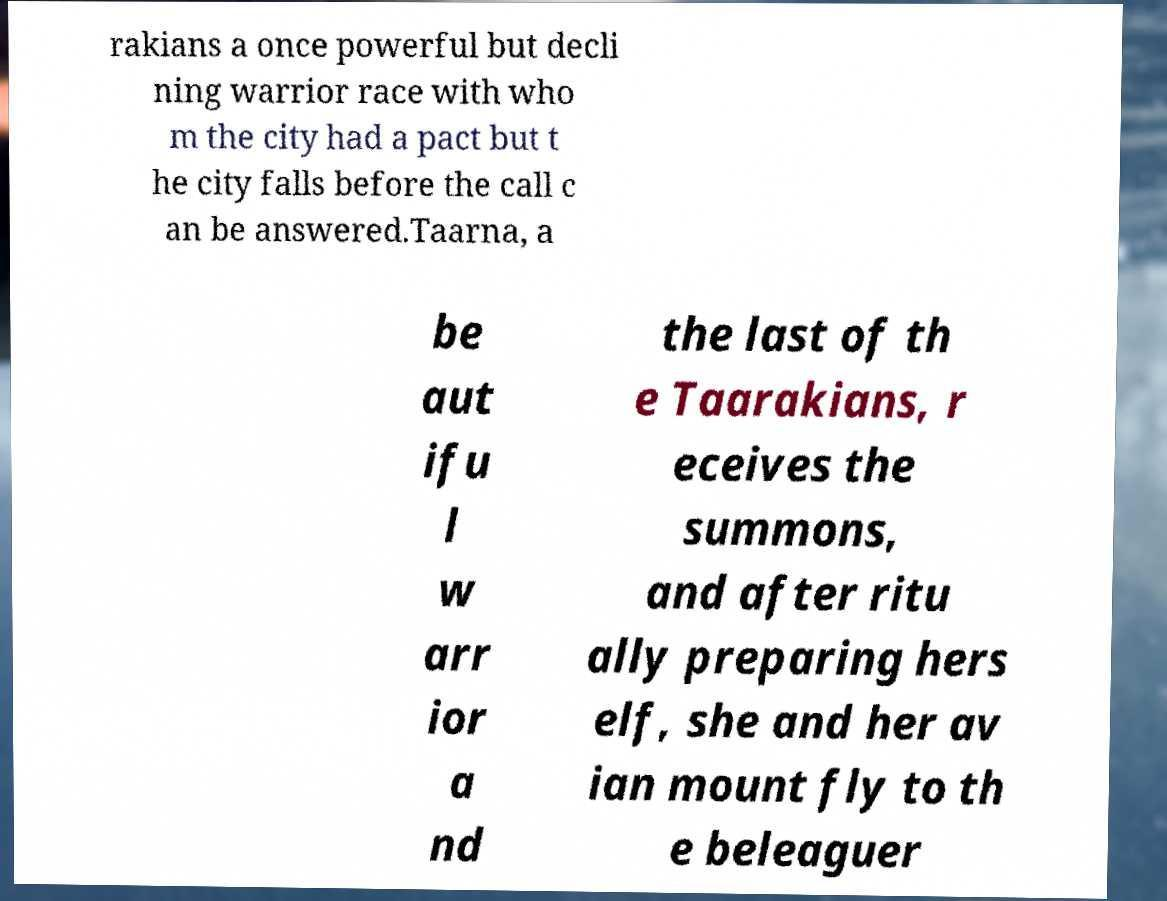For documentation purposes, I need the text within this image transcribed. Could you provide that? rakians a once powerful but decli ning warrior race with who m the city had a pact but t he city falls before the call c an be answered.Taarna, a be aut ifu l w arr ior a nd the last of th e Taarakians, r eceives the summons, and after ritu ally preparing hers elf, she and her av ian mount fly to th e beleaguer 